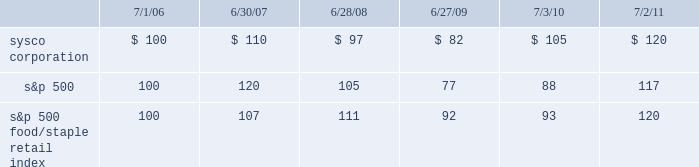Stock performance graph the following performance graph and related information shall not be deemed 201csoliciting material 201d or to be 201cfiled 201d with the securities and exchange commission , nor shall such information be incorporated by reference into any future filing under the securities act of 1933 or the securities exchange act of 1934 , each as amended , except to the extent that sysco specifically incorporates such information by reference into such filing .
The following stock performance graph compares the performance of sysco 2019s common stock to the s&p 500 index and to the s&p 500 food/ staple retail index for sysco 2019s last five fiscal years .
The graph assumes that the value of the investment in our common stock , the s&p 500 index , and the s&p 500 food/staple index was $ 100 on the last trading day of fiscal 2006 , and that all dividends were reinvested .
Performance data for sysco , the s&p 500 index and the s&p 500 food/ staple retail index is provided as of the last trading day of each of our last five fiscal years .
Comparison of 5 year cumulative total return assumes initial investment of $ 100 .

What was the difference in percentage return of sysco corporation and the s&p 500 for the five years ended 7/2/11? 
Computations: (((120 - 100) / 100) - ((117 - 100) / 100))
Answer: 0.03. 